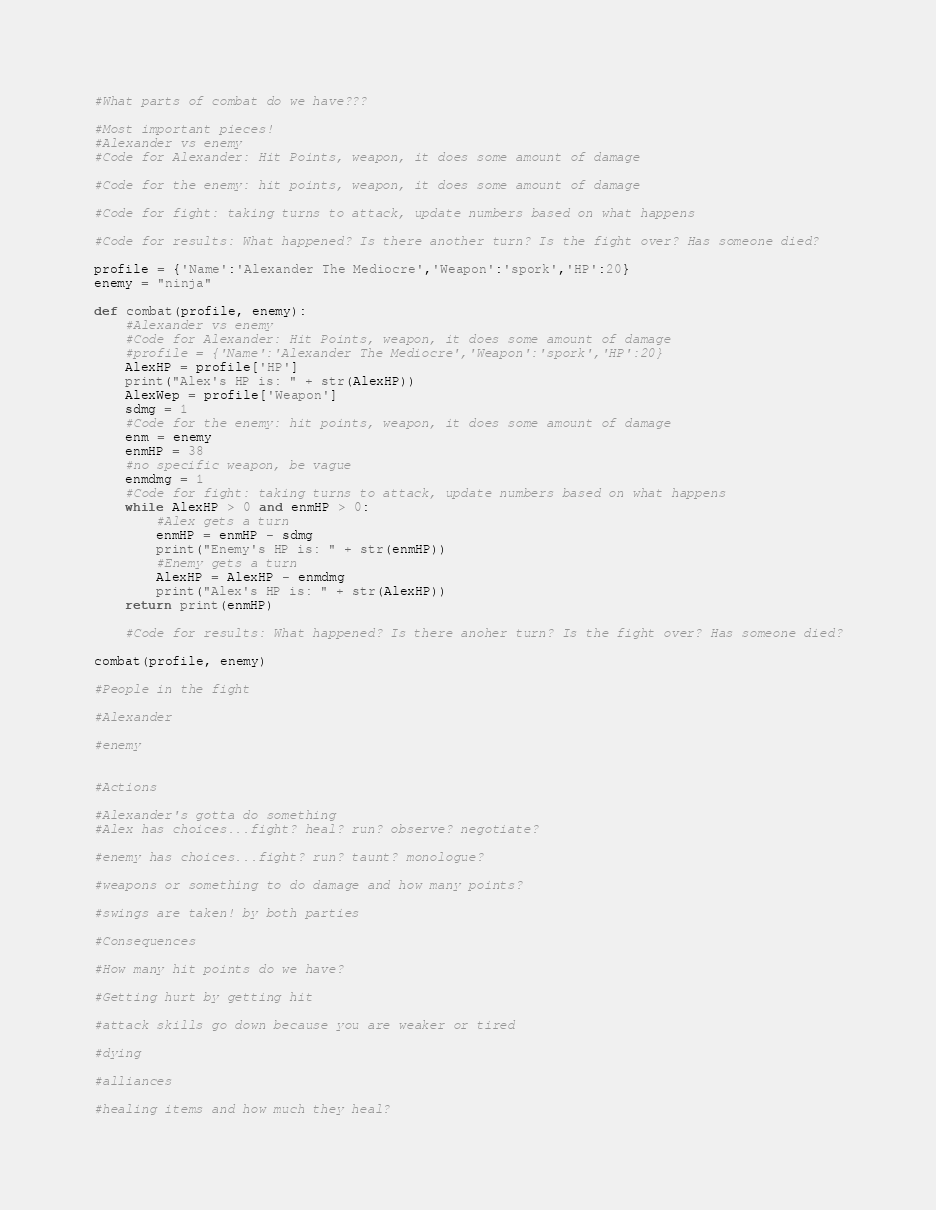Convert code to text. <code><loc_0><loc_0><loc_500><loc_500><_Python_>#What parts of combat do we have???

#Most important pieces!
#Alexander vs enemy
#Code for Alexander: Hit Points, weapon, it does some amount of damage

#Code for the enemy: hit points, weapon, it does some amount of damage

#Code for fight: taking turns to attack, update numbers based on what happens

#Code for results: What happened? Is there another turn? Is the fight over? Has someone died?

profile = {'Name':'Alexander The Mediocre','Weapon':'spork','HP':20}
enemy = "ninja"

def combat(profile, enemy):
    #Alexander vs enemy
    #Code for Alexander: Hit Points, weapon, it does some amount of damage
    #profile = {'Name':'Alexander The Mediocre','Weapon':'spork','HP':20}
    AlexHP = profile['HP']
    print("Alex's HP is: " + str(AlexHP))
    AlexWep = profile['Weapon']
    sdmg = 1
    #Code for the enemy: hit points, weapon, it does some amount of damage
    enm = enemy
    enmHP = 38
    #no specific weapon, be vague
    enmdmg = 1
    #Code for fight: taking turns to attack, update numbers based on what happens
    while AlexHP > 0 and enmHP > 0:
        #Alex gets a turn
        enmHP = enmHP - sdmg
        print("Enemy's HP is: " + str(enmHP))
        #Enemy gets a turn
        AlexHP = AlexHP - enmdmg
        print("Alex's HP is: " + str(AlexHP))
    return print(enmHP)

    #Code for results: What happened? Is there anoher turn? Is the fight over? Has someone died?

combat(profile, enemy)

#People in the fight

#Alexander

#enemy


#Actions

#Alexander's gotta do something
#Alex has choices...fight? heal? run? observe? negotiate?

#enemy has choices...fight? run? taunt? monologue?

#weapons or something to do damage and how many points?

#swings are taken! by both parties

#Consequences

#How many hit points do we have? 

#Getting hurt by getting hit

#attack skills go down because you are weaker or tired

#dying

#alliances

#healing items and how much they heal?
</code> 